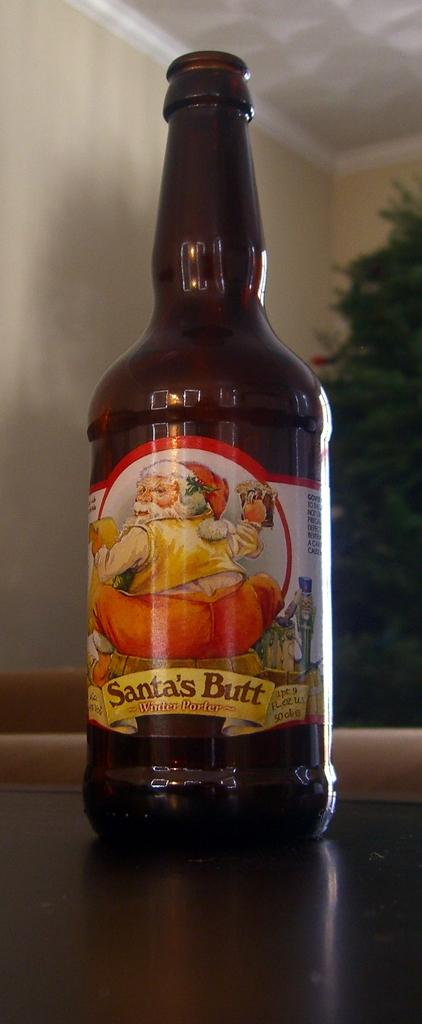What object can be seen in the image? There is a bottle in the image. What can be seen in the background of the image? There is a tree and a wall in the background of the image. What type of protest is happening in the image? There is no protest present in the image; it only features a bottle and a background with a tree and a wall. 